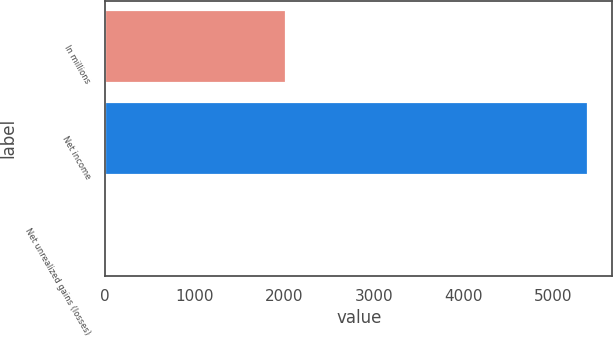Convert chart. <chart><loc_0><loc_0><loc_500><loc_500><bar_chart><fcel>In millions<fcel>Net income<fcel>Net unrealized gains (losses)<nl><fcel>2017<fcel>5388<fcel>16<nl></chart> 